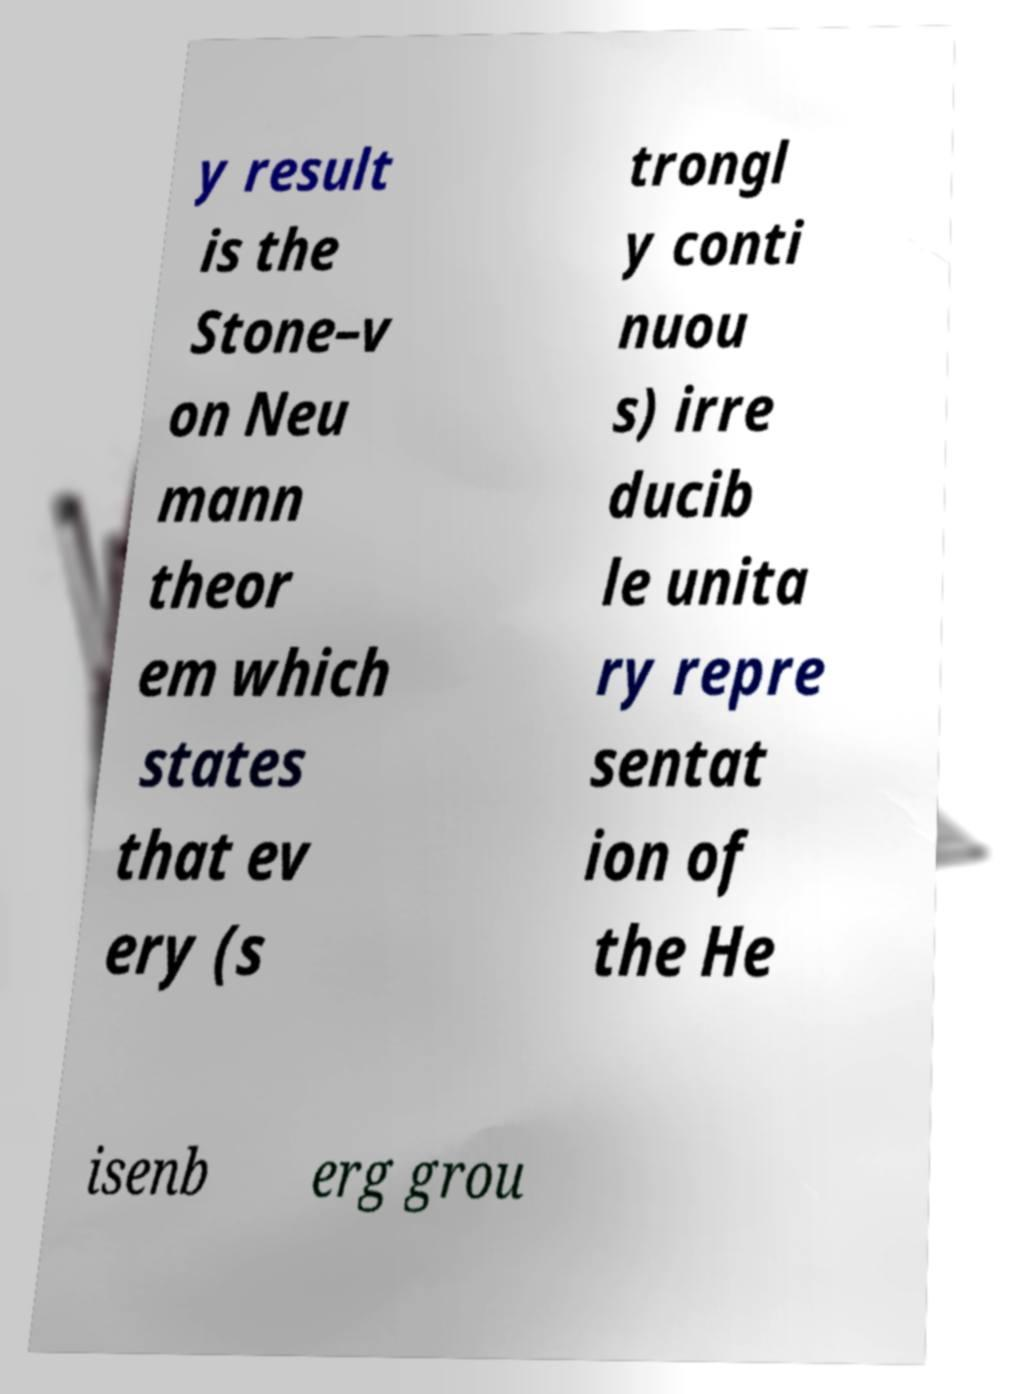Please identify and transcribe the text found in this image. y result is the Stone–v on Neu mann theor em which states that ev ery (s trongl y conti nuou s) irre ducib le unita ry repre sentat ion of the He isenb erg grou 